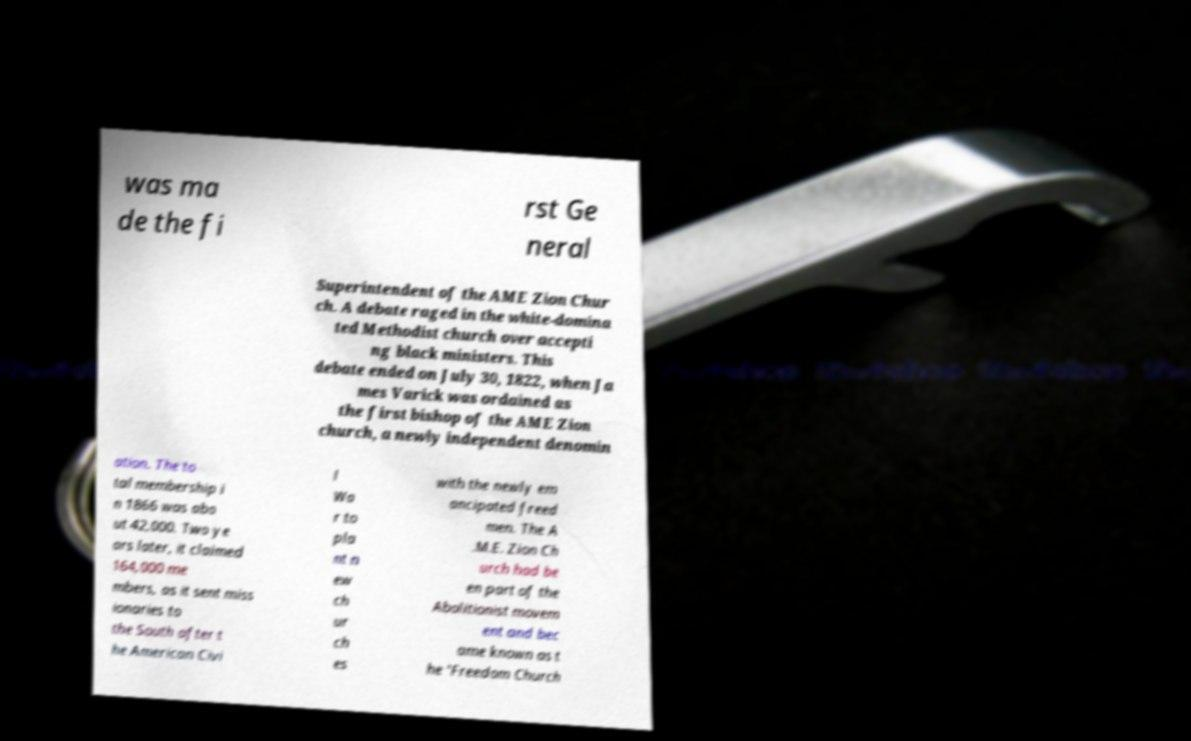For documentation purposes, I need the text within this image transcribed. Could you provide that? was ma de the fi rst Ge neral Superintendent of the AME Zion Chur ch. A debate raged in the white-domina ted Methodist church over accepti ng black ministers. This debate ended on July 30, 1822, when Ja mes Varick was ordained as the first bishop of the AME Zion church, a newly independent denomin ation. The to tal membership i n 1866 was abo ut 42,000. Two ye ars later, it claimed 164,000 me mbers, as it sent miss ionaries to the South after t he American Civi l Wa r to pla nt n ew ch ur ch es with the newly em ancipated freed men. The A .M.E. Zion Ch urch had be en part of the Abolitionist movem ent and bec ame known as t he 'Freedom Church 